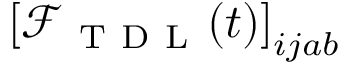<formula> <loc_0><loc_0><loc_500><loc_500>\left [ \mathcal { F } _ { T D L } ( t ) \right ] _ { i j a b }</formula> 